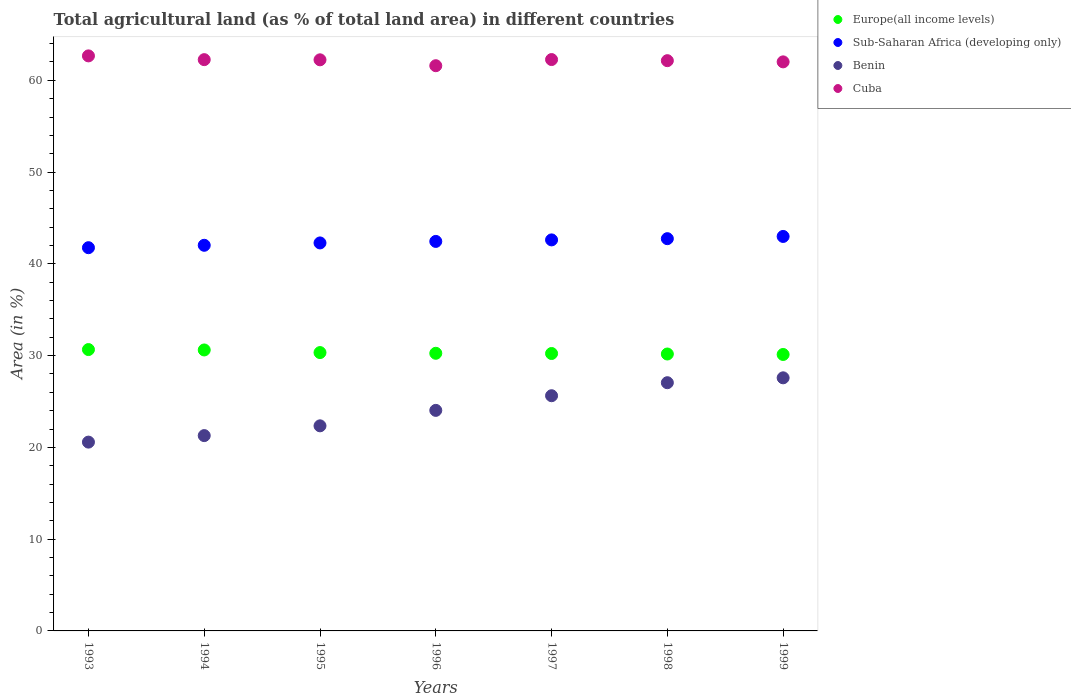What is the percentage of agricultural land in Cuba in 1999?
Ensure brevity in your answer.  62.01. Across all years, what is the maximum percentage of agricultural land in Europe(all income levels)?
Keep it short and to the point. 30.66. Across all years, what is the minimum percentage of agricultural land in Benin?
Your answer should be very brief. 20.57. In which year was the percentage of agricultural land in Europe(all income levels) maximum?
Offer a very short reply. 1993. In which year was the percentage of agricultural land in Sub-Saharan Africa (developing only) minimum?
Give a very brief answer. 1993. What is the total percentage of agricultural land in Cuba in the graph?
Your answer should be compact. 435.16. What is the difference between the percentage of agricultural land in Cuba in 1994 and that in 1995?
Your response must be concise. 0.02. What is the difference between the percentage of agricultural land in Cuba in 1995 and the percentage of agricultural land in Europe(all income levels) in 1996?
Ensure brevity in your answer.  31.98. What is the average percentage of agricultural land in Cuba per year?
Give a very brief answer. 62.17. In the year 1999, what is the difference between the percentage of agricultural land in Cuba and percentage of agricultural land in Benin?
Ensure brevity in your answer.  34.43. What is the ratio of the percentage of agricultural land in Sub-Saharan Africa (developing only) in 1995 to that in 1997?
Make the answer very short. 0.99. Is the difference between the percentage of agricultural land in Cuba in 1996 and 1998 greater than the difference between the percentage of agricultural land in Benin in 1996 and 1998?
Make the answer very short. Yes. What is the difference between the highest and the second highest percentage of agricultural land in Cuba?
Offer a very short reply. 0.4. What is the difference between the highest and the lowest percentage of agricultural land in Benin?
Your answer should be compact. 7.01. Is the sum of the percentage of agricultural land in Europe(all income levels) in 1994 and 1995 greater than the maximum percentage of agricultural land in Cuba across all years?
Offer a terse response. No. Is it the case that in every year, the sum of the percentage of agricultural land in Benin and percentage of agricultural land in Europe(all income levels)  is greater than the sum of percentage of agricultural land in Cuba and percentage of agricultural land in Sub-Saharan Africa (developing only)?
Your answer should be compact. Yes. Is it the case that in every year, the sum of the percentage of agricultural land in Cuba and percentage of agricultural land in Sub-Saharan Africa (developing only)  is greater than the percentage of agricultural land in Benin?
Give a very brief answer. Yes. Is the percentage of agricultural land in Europe(all income levels) strictly greater than the percentage of agricultural land in Benin over the years?
Make the answer very short. Yes. Are the values on the major ticks of Y-axis written in scientific E-notation?
Provide a succinct answer. No. Does the graph contain grids?
Your response must be concise. No. Where does the legend appear in the graph?
Keep it short and to the point. Top right. What is the title of the graph?
Offer a terse response. Total agricultural land (as % of total land area) in different countries. Does "Cuba" appear as one of the legend labels in the graph?
Provide a short and direct response. Yes. What is the label or title of the X-axis?
Provide a short and direct response. Years. What is the label or title of the Y-axis?
Provide a succinct answer. Area (in %). What is the Area (in %) of Europe(all income levels) in 1993?
Your answer should be very brief. 30.66. What is the Area (in %) of Sub-Saharan Africa (developing only) in 1993?
Your answer should be compact. 41.76. What is the Area (in %) of Benin in 1993?
Your response must be concise. 20.57. What is the Area (in %) in Cuba in 1993?
Your response must be concise. 62.66. What is the Area (in %) of Europe(all income levels) in 1994?
Provide a short and direct response. 30.62. What is the Area (in %) in Sub-Saharan Africa (developing only) in 1994?
Ensure brevity in your answer.  42.02. What is the Area (in %) in Benin in 1994?
Give a very brief answer. 21.28. What is the Area (in %) in Cuba in 1994?
Provide a succinct answer. 62.25. What is the Area (in %) of Europe(all income levels) in 1995?
Provide a short and direct response. 30.33. What is the Area (in %) of Sub-Saharan Africa (developing only) in 1995?
Your answer should be compact. 42.28. What is the Area (in %) in Benin in 1995?
Ensure brevity in your answer.  22.35. What is the Area (in %) in Cuba in 1995?
Provide a short and direct response. 62.23. What is the Area (in %) of Europe(all income levels) in 1996?
Offer a very short reply. 30.25. What is the Area (in %) of Sub-Saharan Africa (developing only) in 1996?
Provide a short and direct response. 42.45. What is the Area (in %) of Benin in 1996?
Your answer should be compact. 24.03. What is the Area (in %) of Cuba in 1996?
Offer a terse response. 61.59. What is the Area (in %) in Europe(all income levels) in 1997?
Offer a terse response. 30.23. What is the Area (in %) of Sub-Saharan Africa (developing only) in 1997?
Provide a short and direct response. 42.61. What is the Area (in %) of Benin in 1997?
Make the answer very short. 25.63. What is the Area (in %) in Cuba in 1997?
Your answer should be very brief. 62.26. What is the Area (in %) of Europe(all income levels) in 1998?
Keep it short and to the point. 30.18. What is the Area (in %) in Sub-Saharan Africa (developing only) in 1998?
Ensure brevity in your answer.  42.74. What is the Area (in %) of Benin in 1998?
Make the answer very short. 27.05. What is the Area (in %) in Cuba in 1998?
Offer a terse response. 62.14. What is the Area (in %) of Europe(all income levels) in 1999?
Provide a short and direct response. 30.12. What is the Area (in %) in Sub-Saharan Africa (developing only) in 1999?
Offer a terse response. 42.99. What is the Area (in %) of Benin in 1999?
Keep it short and to the point. 27.58. What is the Area (in %) in Cuba in 1999?
Your answer should be very brief. 62.01. Across all years, what is the maximum Area (in %) in Europe(all income levels)?
Make the answer very short. 30.66. Across all years, what is the maximum Area (in %) of Sub-Saharan Africa (developing only)?
Provide a short and direct response. 42.99. Across all years, what is the maximum Area (in %) of Benin?
Make the answer very short. 27.58. Across all years, what is the maximum Area (in %) of Cuba?
Ensure brevity in your answer.  62.66. Across all years, what is the minimum Area (in %) in Europe(all income levels)?
Your answer should be compact. 30.12. Across all years, what is the minimum Area (in %) of Sub-Saharan Africa (developing only)?
Make the answer very short. 41.76. Across all years, what is the minimum Area (in %) of Benin?
Give a very brief answer. 20.57. Across all years, what is the minimum Area (in %) in Cuba?
Offer a terse response. 61.59. What is the total Area (in %) of Europe(all income levels) in the graph?
Give a very brief answer. 212.39. What is the total Area (in %) in Sub-Saharan Africa (developing only) in the graph?
Ensure brevity in your answer.  296.85. What is the total Area (in %) in Benin in the graph?
Offer a very short reply. 168.5. What is the total Area (in %) in Cuba in the graph?
Your answer should be very brief. 435.16. What is the difference between the Area (in %) of Europe(all income levels) in 1993 and that in 1994?
Offer a terse response. 0.04. What is the difference between the Area (in %) of Sub-Saharan Africa (developing only) in 1993 and that in 1994?
Keep it short and to the point. -0.26. What is the difference between the Area (in %) of Benin in 1993 and that in 1994?
Ensure brevity in your answer.  -0.71. What is the difference between the Area (in %) of Cuba in 1993 and that in 1994?
Your answer should be compact. 0.41. What is the difference between the Area (in %) in Europe(all income levels) in 1993 and that in 1995?
Provide a succinct answer. 0.33. What is the difference between the Area (in %) of Sub-Saharan Africa (developing only) in 1993 and that in 1995?
Ensure brevity in your answer.  -0.52. What is the difference between the Area (in %) of Benin in 1993 and that in 1995?
Provide a short and direct response. -1.77. What is the difference between the Area (in %) in Cuba in 1993 and that in 1995?
Make the answer very short. 0.43. What is the difference between the Area (in %) of Europe(all income levels) in 1993 and that in 1996?
Give a very brief answer. 0.41. What is the difference between the Area (in %) in Sub-Saharan Africa (developing only) in 1993 and that in 1996?
Your answer should be compact. -0.68. What is the difference between the Area (in %) in Benin in 1993 and that in 1996?
Provide a succinct answer. -3.46. What is the difference between the Area (in %) in Cuba in 1993 and that in 1996?
Your answer should be compact. 1.07. What is the difference between the Area (in %) in Europe(all income levels) in 1993 and that in 1997?
Give a very brief answer. 0.43. What is the difference between the Area (in %) of Sub-Saharan Africa (developing only) in 1993 and that in 1997?
Ensure brevity in your answer.  -0.85. What is the difference between the Area (in %) in Benin in 1993 and that in 1997?
Keep it short and to the point. -5.05. What is the difference between the Area (in %) of Cuba in 1993 and that in 1997?
Give a very brief answer. 0.4. What is the difference between the Area (in %) in Europe(all income levels) in 1993 and that in 1998?
Keep it short and to the point. 0.48. What is the difference between the Area (in %) of Sub-Saharan Africa (developing only) in 1993 and that in 1998?
Keep it short and to the point. -0.98. What is the difference between the Area (in %) in Benin in 1993 and that in 1998?
Offer a terse response. -6.47. What is the difference between the Area (in %) of Cuba in 1993 and that in 1998?
Your response must be concise. 0.52. What is the difference between the Area (in %) in Europe(all income levels) in 1993 and that in 1999?
Your answer should be very brief. 0.54. What is the difference between the Area (in %) of Sub-Saharan Africa (developing only) in 1993 and that in 1999?
Make the answer very short. -1.23. What is the difference between the Area (in %) in Benin in 1993 and that in 1999?
Your response must be concise. -7.01. What is the difference between the Area (in %) of Cuba in 1993 and that in 1999?
Provide a succinct answer. 0.65. What is the difference between the Area (in %) of Europe(all income levels) in 1994 and that in 1995?
Ensure brevity in your answer.  0.29. What is the difference between the Area (in %) of Sub-Saharan Africa (developing only) in 1994 and that in 1995?
Offer a terse response. -0.26. What is the difference between the Area (in %) in Benin in 1994 and that in 1995?
Offer a terse response. -1.06. What is the difference between the Area (in %) in Cuba in 1994 and that in 1995?
Provide a short and direct response. 0.02. What is the difference between the Area (in %) of Europe(all income levels) in 1994 and that in 1996?
Provide a succinct answer. 0.36. What is the difference between the Area (in %) of Sub-Saharan Africa (developing only) in 1994 and that in 1996?
Your response must be concise. -0.42. What is the difference between the Area (in %) of Benin in 1994 and that in 1996?
Make the answer very short. -2.75. What is the difference between the Area (in %) in Cuba in 1994 and that in 1996?
Your response must be concise. 0.66. What is the difference between the Area (in %) of Europe(all income levels) in 1994 and that in 1997?
Offer a very short reply. 0.39. What is the difference between the Area (in %) in Sub-Saharan Africa (developing only) in 1994 and that in 1997?
Keep it short and to the point. -0.59. What is the difference between the Area (in %) of Benin in 1994 and that in 1997?
Provide a short and direct response. -4.35. What is the difference between the Area (in %) in Cuba in 1994 and that in 1997?
Ensure brevity in your answer.  -0.01. What is the difference between the Area (in %) in Europe(all income levels) in 1994 and that in 1998?
Provide a short and direct response. 0.44. What is the difference between the Area (in %) in Sub-Saharan Africa (developing only) in 1994 and that in 1998?
Make the answer very short. -0.72. What is the difference between the Area (in %) of Benin in 1994 and that in 1998?
Your response must be concise. -5.76. What is the difference between the Area (in %) in Cuba in 1994 and that in 1998?
Keep it short and to the point. 0.11. What is the difference between the Area (in %) in Europe(all income levels) in 1994 and that in 1999?
Your response must be concise. 0.49. What is the difference between the Area (in %) in Sub-Saharan Africa (developing only) in 1994 and that in 1999?
Provide a short and direct response. -0.96. What is the difference between the Area (in %) of Benin in 1994 and that in 1999?
Make the answer very short. -6.3. What is the difference between the Area (in %) in Cuba in 1994 and that in 1999?
Offer a terse response. 0.24. What is the difference between the Area (in %) of Europe(all income levels) in 1995 and that in 1996?
Keep it short and to the point. 0.08. What is the difference between the Area (in %) in Sub-Saharan Africa (developing only) in 1995 and that in 1996?
Your answer should be compact. -0.17. What is the difference between the Area (in %) of Benin in 1995 and that in 1996?
Offer a very short reply. -1.69. What is the difference between the Area (in %) in Cuba in 1995 and that in 1996?
Make the answer very short. 0.64. What is the difference between the Area (in %) in Europe(all income levels) in 1995 and that in 1997?
Ensure brevity in your answer.  0.1. What is the difference between the Area (in %) in Sub-Saharan Africa (developing only) in 1995 and that in 1997?
Make the answer very short. -0.33. What is the difference between the Area (in %) of Benin in 1995 and that in 1997?
Keep it short and to the point. -3.28. What is the difference between the Area (in %) in Cuba in 1995 and that in 1997?
Offer a terse response. -0.03. What is the difference between the Area (in %) in Europe(all income levels) in 1995 and that in 1998?
Your answer should be compact. 0.16. What is the difference between the Area (in %) of Sub-Saharan Africa (developing only) in 1995 and that in 1998?
Make the answer very short. -0.46. What is the difference between the Area (in %) in Benin in 1995 and that in 1998?
Your answer should be very brief. -4.7. What is the difference between the Area (in %) in Cuba in 1995 and that in 1998?
Provide a short and direct response. 0.09. What is the difference between the Area (in %) in Europe(all income levels) in 1995 and that in 1999?
Offer a very short reply. 0.21. What is the difference between the Area (in %) in Sub-Saharan Africa (developing only) in 1995 and that in 1999?
Keep it short and to the point. -0.71. What is the difference between the Area (in %) of Benin in 1995 and that in 1999?
Offer a very short reply. -5.23. What is the difference between the Area (in %) in Cuba in 1995 and that in 1999?
Your answer should be compact. 0.22. What is the difference between the Area (in %) of Europe(all income levels) in 1996 and that in 1997?
Your answer should be compact. 0.02. What is the difference between the Area (in %) of Sub-Saharan Africa (developing only) in 1996 and that in 1997?
Your answer should be compact. -0.17. What is the difference between the Area (in %) of Benin in 1996 and that in 1997?
Your answer should be very brief. -1.6. What is the difference between the Area (in %) of Cuba in 1996 and that in 1997?
Ensure brevity in your answer.  -0.67. What is the difference between the Area (in %) of Europe(all income levels) in 1996 and that in 1998?
Your answer should be compact. 0.08. What is the difference between the Area (in %) in Sub-Saharan Africa (developing only) in 1996 and that in 1998?
Offer a very short reply. -0.3. What is the difference between the Area (in %) of Benin in 1996 and that in 1998?
Offer a very short reply. -3.02. What is the difference between the Area (in %) in Cuba in 1996 and that in 1998?
Make the answer very short. -0.55. What is the difference between the Area (in %) in Europe(all income levels) in 1996 and that in 1999?
Make the answer very short. 0.13. What is the difference between the Area (in %) of Sub-Saharan Africa (developing only) in 1996 and that in 1999?
Your response must be concise. -0.54. What is the difference between the Area (in %) of Benin in 1996 and that in 1999?
Ensure brevity in your answer.  -3.55. What is the difference between the Area (in %) in Cuba in 1996 and that in 1999?
Offer a terse response. -0.42. What is the difference between the Area (in %) in Europe(all income levels) in 1997 and that in 1998?
Offer a terse response. 0.05. What is the difference between the Area (in %) of Sub-Saharan Africa (developing only) in 1997 and that in 1998?
Keep it short and to the point. -0.13. What is the difference between the Area (in %) of Benin in 1997 and that in 1998?
Offer a very short reply. -1.42. What is the difference between the Area (in %) of Cuba in 1997 and that in 1998?
Provide a succinct answer. 0.12. What is the difference between the Area (in %) in Europe(all income levels) in 1997 and that in 1999?
Ensure brevity in your answer.  0.11. What is the difference between the Area (in %) in Sub-Saharan Africa (developing only) in 1997 and that in 1999?
Give a very brief answer. -0.38. What is the difference between the Area (in %) in Benin in 1997 and that in 1999?
Offer a very short reply. -1.95. What is the difference between the Area (in %) of Cuba in 1997 and that in 1999?
Offer a very short reply. 0.25. What is the difference between the Area (in %) of Europe(all income levels) in 1998 and that in 1999?
Your answer should be compact. 0.05. What is the difference between the Area (in %) of Sub-Saharan Africa (developing only) in 1998 and that in 1999?
Offer a very short reply. -0.24. What is the difference between the Area (in %) in Benin in 1998 and that in 1999?
Make the answer very short. -0.53. What is the difference between the Area (in %) of Cuba in 1998 and that in 1999?
Your answer should be very brief. 0.13. What is the difference between the Area (in %) of Europe(all income levels) in 1993 and the Area (in %) of Sub-Saharan Africa (developing only) in 1994?
Give a very brief answer. -11.36. What is the difference between the Area (in %) of Europe(all income levels) in 1993 and the Area (in %) of Benin in 1994?
Provide a succinct answer. 9.38. What is the difference between the Area (in %) in Europe(all income levels) in 1993 and the Area (in %) in Cuba in 1994?
Keep it short and to the point. -31.59. What is the difference between the Area (in %) in Sub-Saharan Africa (developing only) in 1993 and the Area (in %) in Benin in 1994?
Your response must be concise. 20.48. What is the difference between the Area (in %) in Sub-Saharan Africa (developing only) in 1993 and the Area (in %) in Cuba in 1994?
Keep it short and to the point. -20.49. What is the difference between the Area (in %) in Benin in 1993 and the Area (in %) in Cuba in 1994?
Your answer should be compact. -41.68. What is the difference between the Area (in %) in Europe(all income levels) in 1993 and the Area (in %) in Sub-Saharan Africa (developing only) in 1995?
Your answer should be compact. -11.62. What is the difference between the Area (in %) of Europe(all income levels) in 1993 and the Area (in %) of Benin in 1995?
Your answer should be compact. 8.31. What is the difference between the Area (in %) in Europe(all income levels) in 1993 and the Area (in %) in Cuba in 1995?
Offer a very short reply. -31.57. What is the difference between the Area (in %) in Sub-Saharan Africa (developing only) in 1993 and the Area (in %) in Benin in 1995?
Your answer should be very brief. 19.41. What is the difference between the Area (in %) of Sub-Saharan Africa (developing only) in 1993 and the Area (in %) of Cuba in 1995?
Your answer should be compact. -20.47. What is the difference between the Area (in %) in Benin in 1993 and the Area (in %) in Cuba in 1995?
Provide a short and direct response. -41.66. What is the difference between the Area (in %) in Europe(all income levels) in 1993 and the Area (in %) in Sub-Saharan Africa (developing only) in 1996?
Keep it short and to the point. -11.79. What is the difference between the Area (in %) of Europe(all income levels) in 1993 and the Area (in %) of Benin in 1996?
Your answer should be very brief. 6.63. What is the difference between the Area (in %) in Europe(all income levels) in 1993 and the Area (in %) in Cuba in 1996?
Your response must be concise. -30.93. What is the difference between the Area (in %) in Sub-Saharan Africa (developing only) in 1993 and the Area (in %) in Benin in 1996?
Your answer should be compact. 17.73. What is the difference between the Area (in %) in Sub-Saharan Africa (developing only) in 1993 and the Area (in %) in Cuba in 1996?
Your answer should be very brief. -19.83. What is the difference between the Area (in %) of Benin in 1993 and the Area (in %) of Cuba in 1996?
Offer a terse response. -41.02. What is the difference between the Area (in %) of Europe(all income levels) in 1993 and the Area (in %) of Sub-Saharan Africa (developing only) in 1997?
Your answer should be compact. -11.95. What is the difference between the Area (in %) of Europe(all income levels) in 1993 and the Area (in %) of Benin in 1997?
Your response must be concise. 5.03. What is the difference between the Area (in %) of Europe(all income levels) in 1993 and the Area (in %) of Cuba in 1997?
Make the answer very short. -31.6. What is the difference between the Area (in %) in Sub-Saharan Africa (developing only) in 1993 and the Area (in %) in Benin in 1997?
Offer a terse response. 16.13. What is the difference between the Area (in %) of Sub-Saharan Africa (developing only) in 1993 and the Area (in %) of Cuba in 1997?
Ensure brevity in your answer.  -20.5. What is the difference between the Area (in %) in Benin in 1993 and the Area (in %) in Cuba in 1997?
Offer a terse response. -41.69. What is the difference between the Area (in %) of Europe(all income levels) in 1993 and the Area (in %) of Sub-Saharan Africa (developing only) in 1998?
Make the answer very short. -12.08. What is the difference between the Area (in %) in Europe(all income levels) in 1993 and the Area (in %) in Benin in 1998?
Your answer should be compact. 3.61. What is the difference between the Area (in %) of Europe(all income levels) in 1993 and the Area (in %) of Cuba in 1998?
Your answer should be very brief. -31.48. What is the difference between the Area (in %) of Sub-Saharan Africa (developing only) in 1993 and the Area (in %) of Benin in 1998?
Keep it short and to the point. 14.71. What is the difference between the Area (in %) of Sub-Saharan Africa (developing only) in 1993 and the Area (in %) of Cuba in 1998?
Your answer should be very brief. -20.38. What is the difference between the Area (in %) in Benin in 1993 and the Area (in %) in Cuba in 1998?
Offer a terse response. -41.57. What is the difference between the Area (in %) of Europe(all income levels) in 1993 and the Area (in %) of Sub-Saharan Africa (developing only) in 1999?
Your answer should be very brief. -12.33. What is the difference between the Area (in %) of Europe(all income levels) in 1993 and the Area (in %) of Benin in 1999?
Your response must be concise. 3.08. What is the difference between the Area (in %) of Europe(all income levels) in 1993 and the Area (in %) of Cuba in 1999?
Keep it short and to the point. -31.35. What is the difference between the Area (in %) of Sub-Saharan Africa (developing only) in 1993 and the Area (in %) of Benin in 1999?
Offer a terse response. 14.18. What is the difference between the Area (in %) of Sub-Saharan Africa (developing only) in 1993 and the Area (in %) of Cuba in 1999?
Offer a terse response. -20.25. What is the difference between the Area (in %) in Benin in 1993 and the Area (in %) in Cuba in 1999?
Offer a terse response. -41.44. What is the difference between the Area (in %) of Europe(all income levels) in 1994 and the Area (in %) of Sub-Saharan Africa (developing only) in 1995?
Ensure brevity in your answer.  -11.66. What is the difference between the Area (in %) in Europe(all income levels) in 1994 and the Area (in %) in Benin in 1995?
Your answer should be very brief. 8.27. What is the difference between the Area (in %) of Europe(all income levels) in 1994 and the Area (in %) of Cuba in 1995?
Ensure brevity in your answer.  -31.62. What is the difference between the Area (in %) of Sub-Saharan Africa (developing only) in 1994 and the Area (in %) of Benin in 1995?
Your answer should be very brief. 19.68. What is the difference between the Area (in %) in Sub-Saharan Africa (developing only) in 1994 and the Area (in %) in Cuba in 1995?
Your answer should be very brief. -20.21. What is the difference between the Area (in %) in Benin in 1994 and the Area (in %) in Cuba in 1995?
Your answer should be very brief. -40.95. What is the difference between the Area (in %) in Europe(all income levels) in 1994 and the Area (in %) in Sub-Saharan Africa (developing only) in 1996?
Keep it short and to the point. -11.83. What is the difference between the Area (in %) of Europe(all income levels) in 1994 and the Area (in %) of Benin in 1996?
Provide a short and direct response. 6.58. What is the difference between the Area (in %) of Europe(all income levels) in 1994 and the Area (in %) of Cuba in 1996?
Offer a very short reply. -30.98. What is the difference between the Area (in %) of Sub-Saharan Africa (developing only) in 1994 and the Area (in %) of Benin in 1996?
Give a very brief answer. 17.99. What is the difference between the Area (in %) in Sub-Saharan Africa (developing only) in 1994 and the Area (in %) in Cuba in 1996?
Ensure brevity in your answer.  -19.57. What is the difference between the Area (in %) in Benin in 1994 and the Area (in %) in Cuba in 1996?
Keep it short and to the point. -40.31. What is the difference between the Area (in %) of Europe(all income levels) in 1994 and the Area (in %) of Sub-Saharan Africa (developing only) in 1997?
Make the answer very short. -11.99. What is the difference between the Area (in %) of Europe(all income levels) in 1994 and the Area (in %) of Benin in 1997?
Make the answer very short. 4.99. What is the difference between the Area (in %) of Europe(all income levels) in 1994 and the Area (in %) of Cuba in 1997?
Keep it short and to the point. -31.65. What is the difference between the Area (in %) in Sub-Saharan Africa (developing only) in 1994 and the Area (in %) in Benin in 1997?
Ensure brevity in your answer.  16.39. What is the difference between the Area (in %) in Sub-Saharan Africa (developing only) in 1994 and the Area (in %) in Cuba in 1997?
Ensure brevity in your answer.  -20.24. What is the difference between the Area (in %) in Benin in 1994 and the Area (in %) in Cuba in 1997?
Keep it short and to the point. -40.98. What is the difference between the Area (in %) of Europe(all income levels) in 1994 and the Area (in %) of Sub-Saharan Africa (developing only) in 1998?
Ensure brevity in your answer.  -12.13. What is the difference between the Area (in %) in Europe(all income levels) in 1994 and the Area (in %) in Benin in 1998?
Your answer should be very brief. 3.57. What is the difference between the Area (in %) in Europe(all income levels) in 1994 and the Area (in %) in Cuba in 1998?
Give a very brief answer. -31.52. What is the difference between the Area (in %) in Sub-Saharan Africa (developing only) in 1994 and the Area (in %) in Benin in 1998?
Give a very brief answer. 14.97. What is the difference between the Area (in %) in Sub-Saharan Africa (developing only) in 1994 and the Area (in %) in Cuba in 1998?
Your response must be concise. -20.12. What is the difference between the Area (in %) in Benin in 1994 and the Area (in %) in Cuba in 1998?
Give a very brief answer. -40.86. What is the difference between the Area (in %) in Europe(all income levels) in 1994 and the Area (in %) in Sub-Saharan Africa (developing only) in 1999?
Provide a succinct answer. -12.37. What is the difference between the Area (in %) of Europe(all income levels) in 1994 and the Area (in %) of Benin in 1999?
Your response must be concise. 3.04. What is the difference between the Area (in %) in Europe(all income levels) in 1994 and the Area (in %) in Cuba in 1999?
Your answer should be compact. -31.39. What is the difference between the Area (in %) of Sub-Saharan Africa (developing only) in 1994 and the Area (in %) of Benin in 1999?
Your answer should be very brief. 14.44. What is the difference between the Area (in %) in Sub-Saharan Africa (developing only) in 1994 and the Area (in %) in Cuba in 1999?
Offer a terse response. -19.99. What is the difference between the Area (in %) in Benin in 1994 and the Area (in %) in Cuba in 1999?
Offer a very short reply. -40.73. What is the difference between the Area (in %) of Europe(all income levels) in 1995 and the Area (in %) of Sub-Saharan Africa (developing only) in 1996?
Offer a very short reply. -12.11. What is the difference between the Area (in %) in Europe(all income levels) in 1995 and the Area (in %) in Benin in 1996?
Provide a succinct answer. 6.3. What is the difference between the Area (in %) in Europe(all income levels) in 1995 and the Area (in %) in Cuba in 1996?
Offer a very short reply. -31.26. What is the difference between the Area (in %) in Sub-Saharan Africa (developing only) in 1995 and the Area (in %) in Benin in 1996?
Offer a very short reply. 18.25. What is the difference between the Area (in %) of Sub-Saharan Africa (developing only) in 1995 and the Area (in %) of Cuba in 1996?
Keep it short and to the point. -19.31. What is the difference between the Area (in %) of Benin in 1995 and the Area (in %) of Cuba in 1996?
Keep it short and to the point. -39.24. What is the difference between the Area (in %) of Europe(all income levels) in 1995 and the Area (in %) of Sub-Saharan Africa (developing only) in 1997?
Your answer should be very brief. -12.28. What is the difference between the Area (in %) of Europe(all income levels) in 1995 and the Area (in %) of Benin in 1997?
Your answer should be very brief. 4.7. What is the difference between the Area (in %) in Europe(all income levels) in 1995 and the Area (in %) in Cuba in 1997?
Ensure brevity in your answer.  -31.93. What is the difference between the Area (in %) of Sub-Saharan Africa (developing only) in 1995 and the Area (in %) of Benin in 1997?
Give a very brief answer. 16.65. What is the difference between the Area (in %) of Sub-Saharan Africa (developing only) in 1995 and the Area (in %) of Cuba in 1997?
Ensure brevity in your answer.  -19.98. What is the difference between the Area (in %) of Benin in 1995 and the Area (in %) of Cuba in 1997?
Offer a very short reply. -39.91. What is the difference between the Area (in %) in Europe(all income levels) in 1995 and the Area (in %) in Sub-Saharan Africa (developing only) in 1998?
Offer a terse response. -12.41. What is the difference between the Area (in %) in Europe(all income levels) in 1995 and the Area (in %) in Benin in 1998?
Offer a terse response. 3.28. What is the difference between the Area (in %) of Europe(all income levels) in 1995 and the Area (in %) of Cuba in 1998?
Make the answer very short. -31.81. What is the difference between the Area (in %) of Sub-Saharan Africa (developing only) in 1995 and the Area (in %) of Benin in 1998?
Provide a short and direct response. 15.23. What is the difference between the Area (in %) of Sub-Saharan Africa (developing only) in 1995 and the Area (in %) of Cuba in 1998?
Your response must be concise. -19.86. What is the difference between the Area (in %) of Benin in 1995 and the Area (in %) of Cuba in 1998?
Offer a very short reply. -39.79. What is the difference between the Area (in %) of Europe(all income levels) in 1995 and the Area (in %) of Sub-Saharan Africa (developing only) in 1999?
Offer a terse response. -12.65. What is the difference between the Area (in %) of Europe(all income levels) in 1995 and the Area (in %) of Benin in 1999?
Your answer should be very brief. 2.75. What is the difference between the Area (in %) in Europe(all income levels) in 1995 and the Area (in %) in Cuba in 1999?
Offer a terse response. -31.68. What is the difference between the Area (in %) of Sub-Saharan Africa (developing only) in 1995 and the Area (in %) of Benin in 1999?
Offer a terse response. 14.7. What is the difference between the Area (in %) in Sub-Saharan Africa (developing only) in 1995 and the Area (in %) in Cuba in 1999?
Offer a terse response. -19.73. What is the difference between the Area (in %) in Benin in 1995 and the Area (in %) in Cuba in 1999?
Ensure brevity in your answer.  -39.66. What is the difference between the Area (in %) of Europe(all income levels) in 1996 and the Area (in %) of Sub-Saharan Africa (developing only) in 1997?
Provide a short and direct response. -12.36. What is the difference between the Area (in %) of Europe(all income levels) in 1996 and the Area (in %) of Benin in 1997?
Give a very brief answer. 4.62. What is the difference between the Area (in %) of Europe(all income levels) in 1996 and the Area (in %) of Cuba in 1997?
Provide a succinct answer. -32.01. What is the difference between the Area (in %) in Sub-Saharan Africa (developing only) in 1996 and the Area (in %) in Benin in 1997?
Offer a terse response. 16.82. What is the difference between the Area (in %) of Sub-Saharan Africa (developing only) in 1996 and the Area (in %) of Cuba in 1997?
Keep it short and to the point. -19.82. What is the difference between the Area (in %) in Benin in 1996 and the Area (in %) in Cuba in 1997?
Offer a terse response. -38.23. What is the difference between the Area (in %) of Europe(all income levels) in 1996 and the Area (in %) of Sub-Saharan Africa (developing only) in 1998?
Make the answer very short. -12.49. What is the difference between the Area (in %) of Europe(all income levels) in 1996 and the Area (in %) of Benin in 1998?
Provide a succinct answer. 3.21. What is the difference between the Area (in %) of Europe(all income levels) in 1996 and the Area (in %) of Cuba in 1998?
Your answer should be very brief. -31.89. What is the difference between the Area (in %) in Sub-Saharan Africa (developing only) in 1996 and the Area (in %) in Benin in 1998?
Offer a very short reply. 15.4. What is the difference between the Area (in %) in Sub-Saharan Africa (developing only) in 1996 and the Area (in %) in Cuba in 1998?
Your answer should be very brief. -19.7. What is the difference between the Area (in %) of Benin in 1996 and the Area (in %) of Cuba in 1998?
Offer a terse response. -38.11. What is the difference between the Area (in %) of Europe(all income levels) in 1996 and the Area (in %) of Sub-Saharan Africa (developing only) in 1999?
Your answer should be very brief. -12.73. What is the difference between the Area (in %) in Europe(all income levels) in 1996 and the Area (in %) in Benin in 1999?
Make the answer very short. 2.67. What is the difference between the Area (in %) of Europe(all income levels) in 1996 and the Area (in %) of Cuba in 1999?
Keep it short and to the point. -31.76. What is the difference between the Area (in %) in Sub-Saharan Africa (developing only) in 1996 and the Area (in %) in Benin in 1999?
Make the answer very short. 14.86. What is the difference between the Area (in %) of Sub-Saharan Africa (developing only) in 1996 and the Area (in %) of Cuba in 1999?
Your answer should be compact. -19.57. What is the difference between the Area (in %) in Benin in 1996 and the Area (in %) in Cuba in 1999?
Ensure brevity in your answer.  -37.98. What is the difference between the Area (in %) in Europe(all income levels) in 1997 and the Area (in %) in Sub-Saharan Africa (developing only) in 1998?
Keep it short and to the point. -12.51. What is the difference between the Area (in %) in Europe(all income levels) in 1997 and the Area (in %) in Benin in 1998?
Make the answer very short. 3.18. What is the difference between the Area (in %) in Europe(all income levels) in 1997 and the Area (in %) in Cuba in 1998?
Your answer should be very brief. -31.91. What is the difference between the Area (in %) in Sub-Saharan Africa (developing only) in 1997 and the Area (in %) in Benin in 1998?
Provide a succinct answer. 15.56. What is the difference between the Area (in %) of Sub-Saharan Africa (developing only) in 1997 and the Area (in %) of Cuba in 1998?
Offer a very short reply. -19.53. What is the difference between the Area (in %) of Benin in 1997 and the Area (in %) of Cuba in 1998?
Give a very brief answer. -36.51. What is the difference between the Area (in %) of Europe(all income levels) in 1997 and the Area (in %) of Sub-Saharan Africa (developing only) in 1999?
Your response must be concise. -12.76. What is the difference between the Area (in %) in Europe(all income levels) in 1997 and the Area (in %) in Benin in 1999?
Your response must be concise. 2.65. What is the difference between the Area (in %) of Europe(all income levels) in 1997 and the Area (in %) of Cuba in 1999?
Make the answer very short. -31.78. What is the difference between the Area (in %) in Sub-Saharan Africa (developing only) in 1997 and the Area (in %) in Benin in 1999?
Keep it short and to the point. 15.03. What is the difference between the Area (in %) in Sub-Saharan Africa (developing only) in 1997 and the Area (in %) in Cuba in 1999?
Provide a short and direct response. -19.4. What is the difference between the Area (in %) of Benin in 1997 and the Area (in %) of Cuba in 1999?
Make the answer very short. -36.38. What is the difference between the Area (in %) of Europe(all income levels) in 1998 and the Area (in %) of Sub-Saharan Africa (developing only) in 1999?
Offer a terse response. -12.81. What is the difference between the Area (in %) of Europe(all income levels) in 1998 and the Area (in %) of Benin in 1999?
Your answer should be compact. 2.6. What is the difference between the Area (in %) of Europe(all income levels) in 1998 and the Area (in %) of Cuba in 1999?
Offer a very short reply. -31.84. What is the difference between the Area (in %) in Sub-Saharan Africa (developing only) in 1998 and the Area (in %) in Benin in 1999?
Your answer should be very brief. 15.16. What is the difference between the Area (in %) of Sub-Saharan Africa (developing only) in 1998 and the Area (in %) of Cuba in 1999?
Make the answer very short. -19.27. What is the difference between the Area (in %) in Benin in 1998 and the Area (in %) in Cuba in 1999?
Offer a terse response. -34.96. What is the average Area (in %) in Europe(all income levels) per year?
Keep it short and to the point. 30.34. What is the average Area (in %) of Sub-Saharan Africa (developing only) per year?
Offer a very short reply. 42.41. What is the average Area (in %) of Benin per year?
Your answer should be very brief. 24.07. What is the average Area (in %) in Cuba per year?
Your response must be concise. 62.17. In the year 1993, what is the difference between the Area (in %) in Europe(all income levels) and Area (in %) in Sub-Saharan Africa (developing only)?
Give a very brief answer. -11.1. In the year 1993, what is the difference between the Area (in %) in Europe(all income levels) and Area (in %) in Benin?
Your answer should be compact. 10.09. In the year 1993, what is the difference between the Area (in %) in Europe(all income levels) and Area (in %) in Cuba?
Offer a very short reply. -32. In the year 1993, what is the difference between the Area (in %) of Sub-Saharan Africa (developing only) and Area (in %) of Benin?
Provide a succinct answer. 21.19. In the year 1993, what is the difference between the Area (in %) of Sub-Saharan Africa (developing only) and Area (in %) of Cuba?
Make the answer very short. -20.9. In the year 1993, what is the difference between the Area (in %) of Benin and Area (in %) of Cuba?
Provide a short and direct response. -42.09. In the year 1994, what is the difference between the Area (in %) of Europe(all income levels) and Area (in %) of Sub-Saharan Africa (developing only)?
Your answer should be very brief. -11.41. In the year 1994, what is the difference between the Area (in %) in Europe(all income levels) and Area (in %) in Benin?
Give a very brief answer. 9.33. In the year 1994, what is the difference between the Area (in %) of Europe(all income levels) and Area (in %) of Cuba?
Your response must be concise. -31.64. In the year 1994, what is the difference between the Area (in %) of Sub-Saharan Africa (developing only) and Area (in %) of Benin?
Provide a short and direct response. 20.74. In the year 1994, what is the difference between the Area (in %) of Sub-Saharan Africa (developing only) and Area (in %) of Cuba?
Give a very brief answer. -20.23. In the year 1994, what is the difference between the Area (in %) of Benin and Area (in %) of Cuba?
Make the answer very short. -40.97. In the year 1995, what is the difference between the Area (in %) in Europe(all income levels) and Area (in %) in Sub-Saharan Africa (developing only)?
Provide a succinct answer. -11.95. In the year 1995, what is the difference between the Area (in %) of Europe(all income levels) and Area (in %) of Benin?
Offer a terse response. 7.98. In the year 1995, what is the difference between the Area (in %) in Europe(all income levels) and Area (in %) in Cuba?
Give a very brief answer. -31.9. In the year 1995, what is the difference between the Area (in %) of Sub-Saharan Africa (developing only) and Area (in %) of Benin?
Your answer should be compact. 19.93. In the year 1995, what is the difference between the Area (in %) of Sub-Saharan Africa (developing only) and Area (in %) of Cuba?
Your response must be concise. -19.95. In the year 1995, what is the difference between the Area (in %) of Benin and Area (in %) of Cuba?
Your response must be concise. -39.89. In the year 1996, what is the difference between the Area (in %) in Europe(all income levels) and Area (in %) in Sub-Saharan Africa (developing only)?
Make the answer very short. -12.19. In the year 1996, what is the difference between the Area (in %) in Europe(all income levels) and Area (in %) in Benin?
Offer a very short reply. 6.22. In the year 1996, what is the difference between the Area (in %) of Europe(all income levels) and Area (in %) of Cuba?
Your answer should be very brief. -31.34. In the year 1996, what is the difference between the Area (in %) of Sub-Saharan Africa (developing only) and Area (in %) of Benin?
Your answer should be compact. 18.41. In the year 1996, what is the difference between the Area (in %) in Sub-Saharan Africa (developing only) and Area (in %) in Cuba?
Give a very brief answer. -19.15. In the year 1996, what is the difference between the Area (in %) in Benin and Area (in %) in Cuba?
Your response must be concise. -37.56. In the year 1997, what is the difference between the Area (in %) in Europe(all income levels) and Area (in %) in Sub-Saharan Africa (developing only)?
Offer a terse response. -12.38. In the year 1997, what is the difference between the Area (in %) of Europe(all income levels) and Area (in %) of Benin?
Keep it short and to the point. 4.6. In the year 1997, what is the difference between the Area (in %) in Europe(all income levels) and Area (in %) in Cuba?
Ensure brevity in your answer.  -32.03. In the year 1997, what is the difference between the Area (in %) in Sub-Saharan Africa (developing only) and Area (in %) in Benin?
Offer a terse response. 16.98. In the year 1997, what is the difference between the Area (in %) in Sub-Saharan Africa (developing only) and Area (in %) in Cuba?
Keep it short and to the point. -19.65. In the year 1997, what is the difference between the Area (in %) in Benin and Area (in %) in Cuba?
Your answer should be compact. -36.63. In the year 1998, what is the difference between the Area (in %) of Europe(all income levels) and Area (in %) of Sub-Saharan Africa (developing only)?
Make the answer very short. -12.57. In the year 1998, what is the difference between the Area (in %) of Europe(all income levels) and Area (in %) of Benin?
Give a very brief answer. 3.13. In the year 1998, what is the difference between the Area (in %) in Europe(all income levels) and Area (in %) in Cuba?
Your response must be concise. -31.97. In the year 1998, what is the difference between the Area (in %) of Sub-Saharan Africa (developing only) and Area (in %) of Benin?
Offer a very short reply. 15.7. In the year 1998, what is the difference between the Area (in %) of Sub-Saharan Africa (developing only) and Area (in %) of Cuba?
Ensure brevity in your answer.  -19.4. In the year 1998, what is the difference between the Area (in %) in Benin and Area (in %) in Cuba?
Keep it short and to the point. -35.09. In the year 1999, what is the difference between the Area (in %) of Europe(all income levels) and Area (in %) of Sub-Saharan Africa (developing only)?
Ensure brevity in your answer.  -12.86. In the year 1999, what is the difference between the Area (in %) in Europe(all income levels) and Area (in %) in Benin?
Provide a short and direct response. 2.54. In the year 1999, what is the difference between the Area (in %) of Europe(all income levels) and Area (in %) of Cuba?
Your response must be concise. -31.89. In the year 1999, what is the difference between the Area (in %) in Sub-Saharan Africa (developing only) and Area (in %) in Benin?
Provide a succinct answer. 15.41. In the year 1999, what is the difference between the Area (in %) of Sub-Saharan Africa (developing only) and Area (in %) of Cuba?
Your response must be concise. -19.02. In the year 1999, what is the difference between the Area (in %) of Benin and Area (in %) of Cuba?
Ensure brevity in your answer.  -34.43. What is the ratio of the Area (in %) of Benin in 1993 to that in 1994?
Provide a short and direct response. 0.97. What is the ratio of the Area (in %) of Cuba in 1993 to that in 1994?
Give a very brief answer. 1.01. What is the ratio of the Area (in %) in Europe(all income levels) in 1993 to that in 1995?
Your response must be concise. 1.01. What is the ratio of the Area (in %) in Benin in 1993 to that in 1995?
Your answer should be compact. 0.92. What is the ratio of the Area (in %) in Europe(all income levels) in 1993 to that in 1996?
Provide a succinct answer. 1.01. What is the ratio of the Area (in %) in Sub-Saharan Africa (developing only) in 1993 to that in 1996?
Keep it short and to the point. 0.98. What is the ratio of the Area (in %) of Benin in 1993 to that in 1996?
Give a very brief answer. 0.86. What is the ratio of the Area (in %) of Cuba in 1993 to that in 1996?
Provide a succinct answer. 1.02. What is the ratio of the Area (in %) of Europe(all income levels) in 1993 to that in 1997?
Your answer should be compact. 1.01. What is the ratio of the Area (in %) of Sub-Saharan Africa (developing only) in 1993 to that in 1997?
Keep it short and to the point. 0.98. What is the ratio of the Area (in %) of Benin in 1993 to that in 1997?
Your answer should be very brief. 0.8. What is the ratio of the Area (in %) of Cuba in 1993 to that in 1997?
Offer a very short reply. 1.01. What is the ratio of the Area (in %) in Europe(all income levels) in 1993 to that in 1998?
Offer a very short reply. 1.02. What is the ratio of the Area (in %) in Benin in 1993 to that in 1998?
Your response must be concise. 0.76. What is the ratio of the Area (in %) in Cuba in 1993 to that in 1998?
Give a very brief answer. 1.01. What is the ratio of the Area (in %) of Europe(all income levels) in 1993 to that in 1999?
Offer a very short reply. 1.02. What is the ratio of the Area (in %) of Sub-Saharan Africa (developing only) in 1993 to that in 1999?
Offer a terse response. 0.97. What is the ratio of the Area (in %) in Benin in 1993 to that in 1999?
Make the answer very short. 0.75. What is the ratio of the Area (in %) in Cuba in 1993 to that in 1999?
Your answer should be very brief. 1.01. What is the ratio of the Area (in %) of Europe(all income levels) in 1994 to that in 1995?
Your answer should be compact. 1.01. What is the ratio of the Area (in %) in Europe(all income levels) in 1994 to that in 1996?
Your response must be concise. 1.01. What is the ratio of the Area (in %) of Sub-Saharan Africa (developing only) in 1994 to that in 1996?
Offer a terse response. 0.99. What is the ratio of the Area (in %) of Benin in 1994 to that in 1996?
Make the answer very short. 0.89. What is the ratio of the Area (in %) of Cuba in 1994 to that in 1996?
Your answer should be compact. 1.01. What is the ratio of the Area (in %) of Europe(all income levels) in 1994 to that in 1997?
Keep it short and to the point. 1.01. What is the ratio of the Area (in %) in Sub-Saharan Africa (developing only) in 1994 to that in 1997?
Your answer should be compact. 0.99. What is the ratio of the Area (in %) of Benin in 1994 to that in 1997?
Your answer should be compact. 0.83. What is the ratio of the Area (in %) in Cuba in 1994 to that in 1997?
Your answer should be very brief. 1. What is the ratio of the Area (in %) of Europe(all income levels) in 1994 to that in 1998?
Provide a succinct answer. 1.01. What is the ratio of the Area (in %) of Sub-Saharan Africa (developing only) in 1994 to that in 1998?
Your response must be concise. 0.98. What is the ratio of the Area (in %) in Benin in 1994 to that in 1998?
Provide a short and direct response. 0.79. What is the ratio of the Area (in %) in Europe(all income levels) in 1994 to that in 1999?
Your answer should be compact. 1.02. What is the ratio of the Area (in %) in Sub-Saharan Africa (developing only) in 1994 to that in 1999?
Provide a succinct answer. 0.98. What is the ratio of the Area (in %) of Benin in 1994 to that in 1999?
Your response must be concise. 0.77. What is the ratio of the Area (in %) of Cuba in 1994 to that in 1999?
Make the answer very short. 1. What is the ratio of the Area (in %) in Europe(all income levels) in 1995 to that in 1996?
Your response must be concise. 1. What is the ratio of the Area (in %) of Benin in 1995 to that in 1996?
Ensure brevity in your answer.  0.93. What is the ratio of the Area (in %) in Cuba in 1995 to that in 1996?
Your answer should be very brief. 1.01. What is the ratio of the Area (in %) in Sub-Saharan Africa (developing only) in 1995 to that in 1997?
Offer a terse response. 0.99. What is the ratio of the Area (in %) in Benin in 1995 to that in 1997?
Keep it short and to the point. 0.87. What is the ratio of the Area (in %) of Europe(all income levels) in 1995 to that in 1998?
Your response must be concise. 1.01. What is the ratio of the Area (in %) in Benin in 1995 to that in 1998?
Provide a short and direct response. 0.83. What is the ratio of the Area (in %) in Cuba in 1995 to that in 1998?
Ensure brevity in your answer.  1. What is the ratio of the Area (in %) in Sub-Saharan Africa (developing only) in 1995 to that in 1999?
Offer a very short reply. 0.98. What is the ratio of the Area (in %) in Benin in 1995 to that in 1999?
Ensure brevity in your answer.  0.81. What is the ratio of the Area (in %) in Europe(all income levels) in 1996 to that in 1997?
Your answer should be very brief. 1. What is the ratio of the Area (in %) of Benin in 1996 to that in 1997?
Your answer should be compact. 0.94. What is the ratio of the Area (in %) in Cuba in 1996 to that in 1997?
Your answer should be very brief. 0.99. What is the ratio of the Area (in %) of Benin in 1996 to that in 1998?
Give a very brief answer. 0.89. What is the ratio of the Area (in %) of Cuba in 1996 to that in 1998?
Provide a succinct answer. 0.99. What is the ratio of the Area (in %) in Europe(all income levels) in 1996 to that in 1999?
Make the answer very short. 1. What is the ratio of the Area (in %) in Sub-Saharan Africa (developing only) in 1996 to that in 1999?
Ensure brevity in your answer.  0.99. What is the ratio of the Area (in %) in Benin in 1996 to that in 1999?
Your response must be concise. 0.87. What is the ratio of the Area (in %) of Cuba in 1996 to that in 1999?
Offer a very short reply. 0.99. What is the ratio of the Area (in %) in Sub-Saharan Africa (developing only) in 1997 to that in 1998?
Your response must be concise. 1. What is the ratio of the Area (in %) of Benin in 1997 to that in 1998?
Your answer should be compact. 0.95. What is the ratio of the Area (in %) of Sub-Saharan Africa (developing only) in 1997 to that in 1999?
Offer a terse response. 0.99. What is the ratio of the Area (in %) of Benin in 1997 to that in 1999?
Ensure brevity in your answer.  0.93. What is the ratio of the Area (in %) in Cuba in 1997 to that in 1999?
Provide a short and direct response. 1. What is the ratio of the Area (in %) of Sub-Saharan Africa (developing only) in 1998 to that in 1999?
Offer a very short reply. 0.99. What is the ratio of the Area (in %) of Benin in 1998 to that in 1999?
Provide a succinct answer. 0.98. What is the difference between the highest and the second highest Area (in %) of Europe(all income levels)?
Your response must be concise. 0.04. What is the difference between the highest and the second highest Area (in %) in Sub-Saharan Africa (developing only)?
Give a very brief answer. 0.24. What is the difference between the highest and the second highest Area (in %) in Benin?
Your answer should be compact. 0.53. What is the difference between the highest and the second highest Area (in %) in Cuba?
Give a very brief answer. 0.4. What is the difference between the highest and the lowest Area (in %) in Europe(all income levels)?
Give a very brief answer. 0.54. What is the difference between the highest and the lowest Area (in %) in Sub-Saharan Africa (developing only)?
Give a very brief answer. 1.23. What is the difference between the highest and the lowest Area (in %) of Benin?
Ensure brevity in your answer.  7.01. What is the difference between the highest and the lowest Area (in %) of Cuba?
Provide a succinct answer. 1.07. 